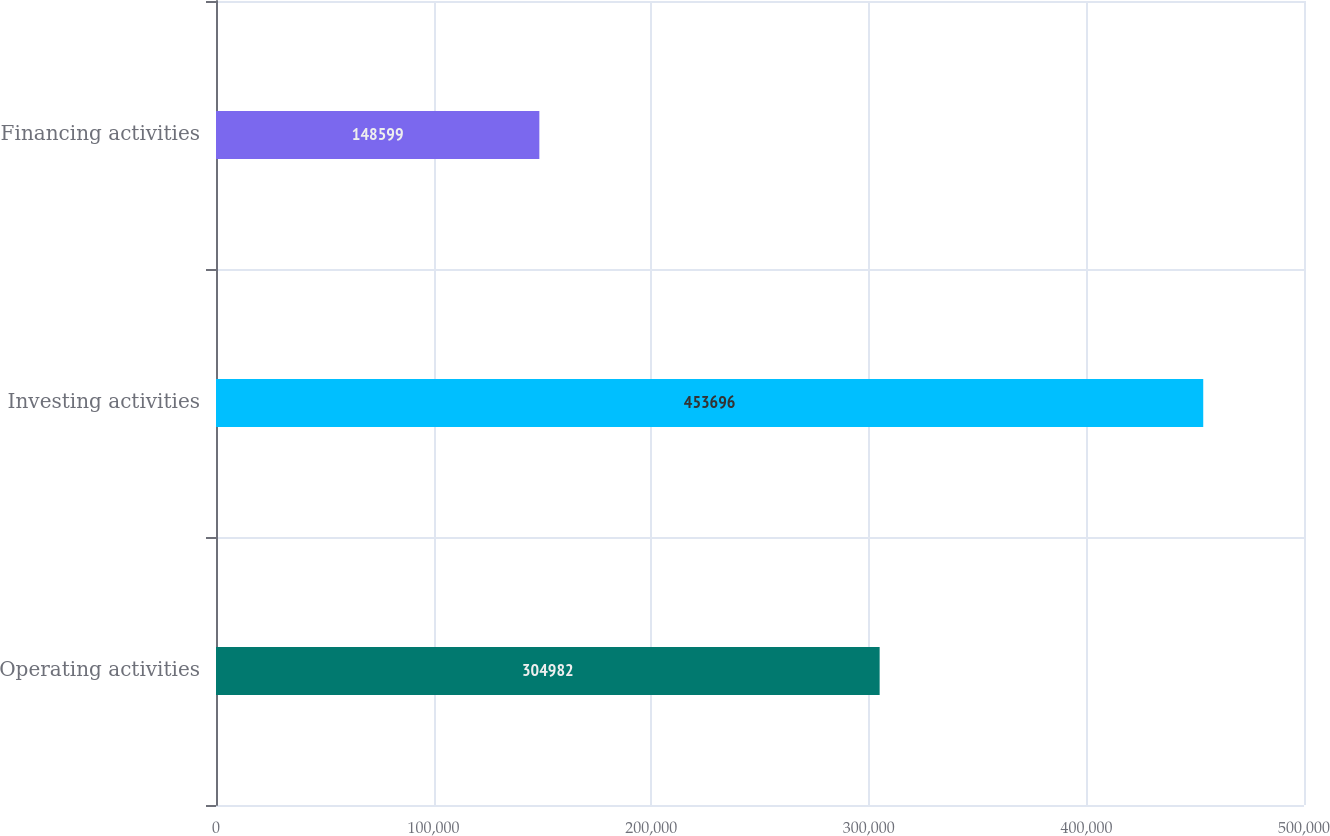<chart> <loc_0><loc_0><loc_500><loc_500><bar_chart><fcel>Operating activities<fcel>Investing activities<fcel>Financing activities<nl><fcel>304982<fcel>453696<fcel>148599<nl></chart> 